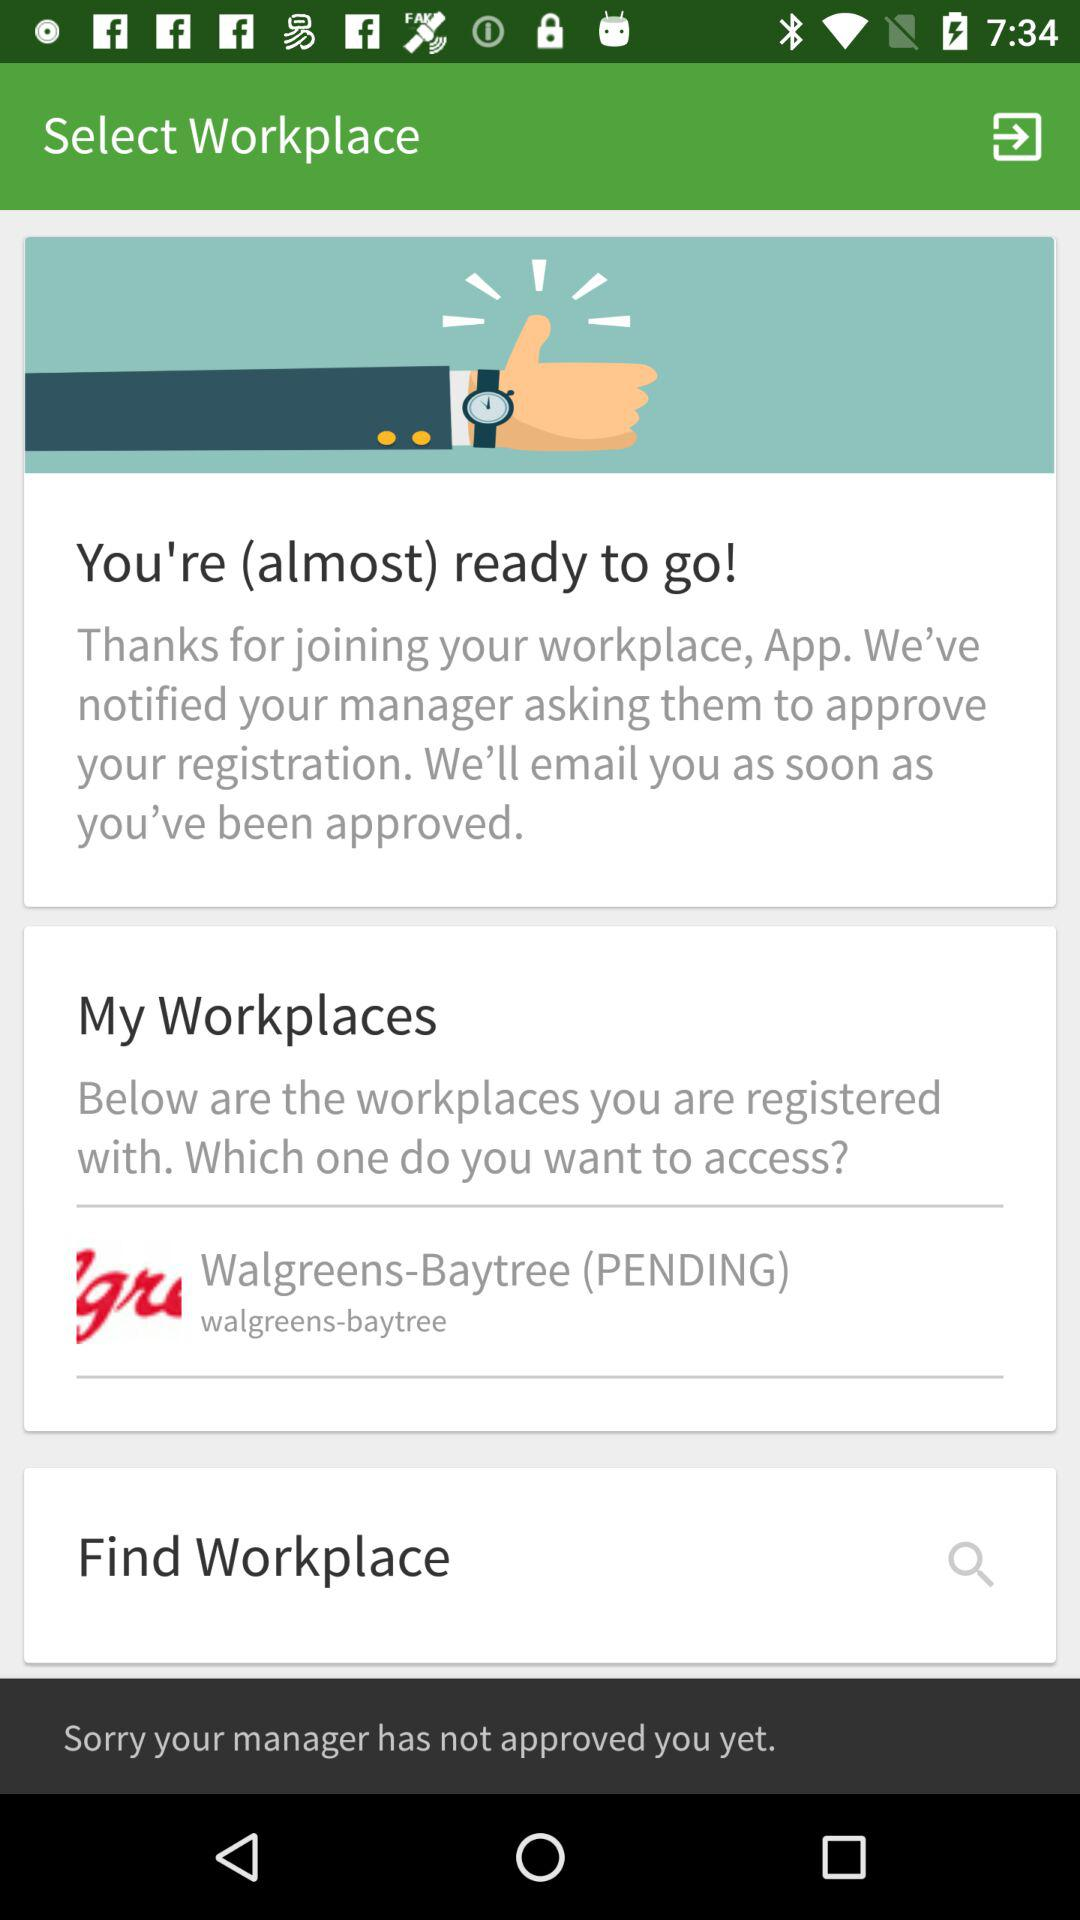How many workplaces are pending approval?
Answer the question using a single word or phrase. 1 